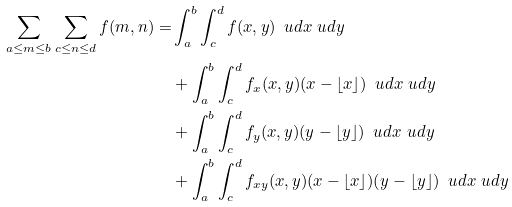<formula> <loc_0><loc_0><loc_500><loc_500>\sum _ { a \leq m \leq b } \sum _ { c \leq n \leq d } f ( m , n ) = & \int _ { a } ^ { b } \int _ { c } ^ { d } f ( x , y ) \, \ u d x \ u d y \\ & + \int _ { a } ^ { b } \int _ { c } ^ { d } f _ { x } ( x , y ) ( x - \lfloor x \rfloor ) \, \ u d x \ u d y \\ & + \int _ { a } ^ { b } \int _ { c } ^ { d } f _ { y } ( x , y ) ( y - \lfloor y \rfloor ) \, \ u d x \ u d y \\ & + \int _ { a } ^ { b } \int _ { c } ^ { d } f _ { x y } ( x , y ) ( x - \lfloor x \rfloor ) ( y - \lfloor y \rfloor ) \, \ u d x \ u d y</formula> 